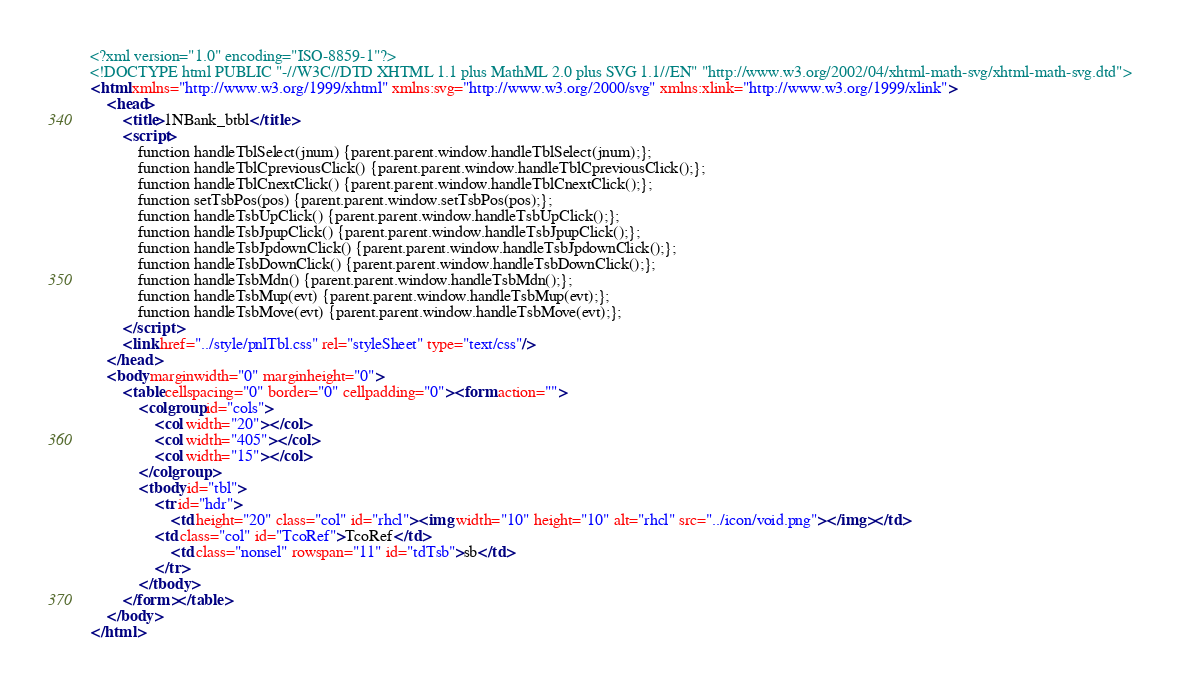Convert code to text. <code><loc_0><loc_0><loc_500><loc_500><_XML_><?xml version="1.0" encoding="ISO-8859-1"?>
<!DOCTYPE html PUBLIC "-//W3C//DTD XHTML 1.1 plus MathML 2.0 plus SVG 1.1//EN" "http://www.w3.org/2002/04/xhtml-math-svg/xhtml-math-svg.dtd">
<html xmlns="http://www.w3.org/1999/xhtml" xmlns:svg="http://www.w3.org/2000/svg" xmlns:xlink="http://www.w3.org/1999/xlink">
	<head>
		<title>1NBank_btbl</title>
		<script>
			function handleTblSelect(jnum) {parent.parent.window.handleTblSelect(jnum);};
			function handleTblCpreviousClick() {parent.parent.window.handleTblCpreviousClick();};
			function handleTblCnextClick() {parent.parent.window.handleTblCnextClick();};
			function setTsbPos(pos) {parent.parent.window.setTsbPos(pos);};
			function handleTsbUpClick() {parent.parent.window.handleTsbUpClick();};
			function handleTsbJpupClick() {parent.parent.window.handleTsbJpupClick();};
			function handleTsbJpdownClick() {parent.parent.window.handleTsbJpdownClick();};
			function handleTsbDownClick() {parent.parent.window.handleTsbDownClick();};
			function handleTsbMdn() {parent.parent.window.handleTsbMdn();};
			function handleTsbMup(evt) {parent.parent.window.handleTsbMup(evt);};
			function handleTsbMove(evt) {parent.parent.window.handleTsbMove(evt);};
		</script>
		<link href="../style/pnlTbl.css" rel="styleSheet" type="text/css"/>
	</head>
	<body marginwidth="0" marginheight="0">
		<table cellspacing="0" border="0" cellpadding="0"><form action="">
			<colgroup id="cols">
				<col width="20"></col>
				<col width="405"></col>
				<col width="15"></col>
			</colgroup>
			<tbody id="tbl">
				<tr id="hdr">
					<td height="20" class="col" id="rhcl"><img width="10" height="10" alt="rhcl" src="../icon/void.png"></img></td>
				<td class="col" id="TcoRef">TcoRef</td>
					<td class="nonsel" rowspan="11" id="tdTsb">sb</td>
				</tr>
			</tbody>
		</form></table>
	</body>
</html>
</code> 